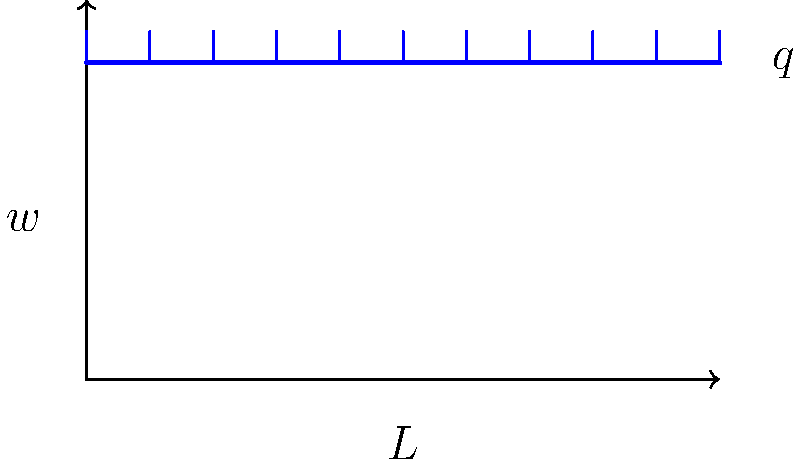A simple beam of length $L$ is subjected to a uniformly distributed load $q$ along its entire length. Calculate the maximum bending moment $M_{max}$ at the center of the beam. Express your answer in terms of $q$ and $L$. To calculate the maximum bending moment for a simple beam with a uniformly distributed load, we can follow these steps:

1. Recognize that for a simple beam with uniform load, the maximum bending moment occurs at the center of the beam.

2. The formula for the maximum bending moment in this case is:

   $$M_{max} = \frac{qL^2}{8}$$

   Where:
   $q$ = uniformly distributed load per unit length
   $L$ = total length of the beam

3. This formula is derived from the general equation for the bending moment in a beam:

   $$M(x) = \frac{qx}{2}(L-x)$$

   Where $x$ is the distance from one end of the beam.

4. At the center of the beam, $x = L/2$, which gives us the maximum moment.

5. By substituting $x = L/2$ into the general equation, we get:

   $$M_{max} = M(L/2) = \frac{q(L/2)}{2}(L-L/2) = \frac{qL}{4} \cdot \frac{L}{2} = \frac{qL^2}{8}$$

This formula allows us to calculate the maximum bending moment using only the load intensity $q$ and the beam length $L$.
Answer: $$M_{max} = \frac{qL^2}{8}$$ 